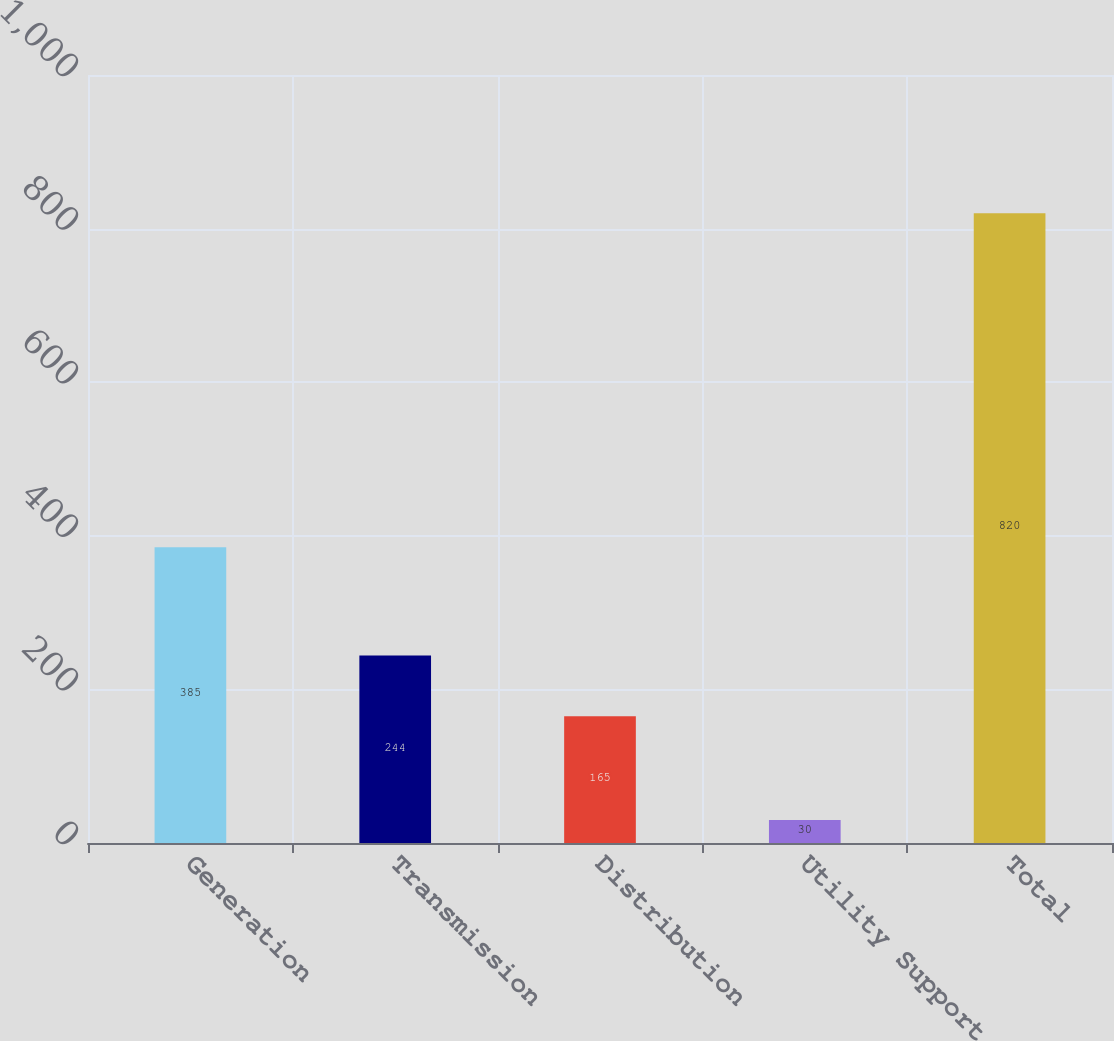<chart> <loc_0><loc_0><loc_500><loc_500><bar_chart><fcel>Generation<fcel>Transmission<fcel>Distribution<fcel>Utility Support<fcel>Total<nl><fcel>385<fcel>244<fcel>165<fcel>30<fcel>820<nl></chart> 